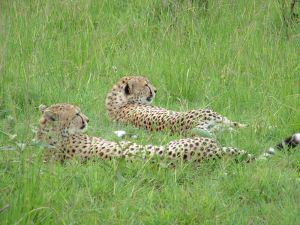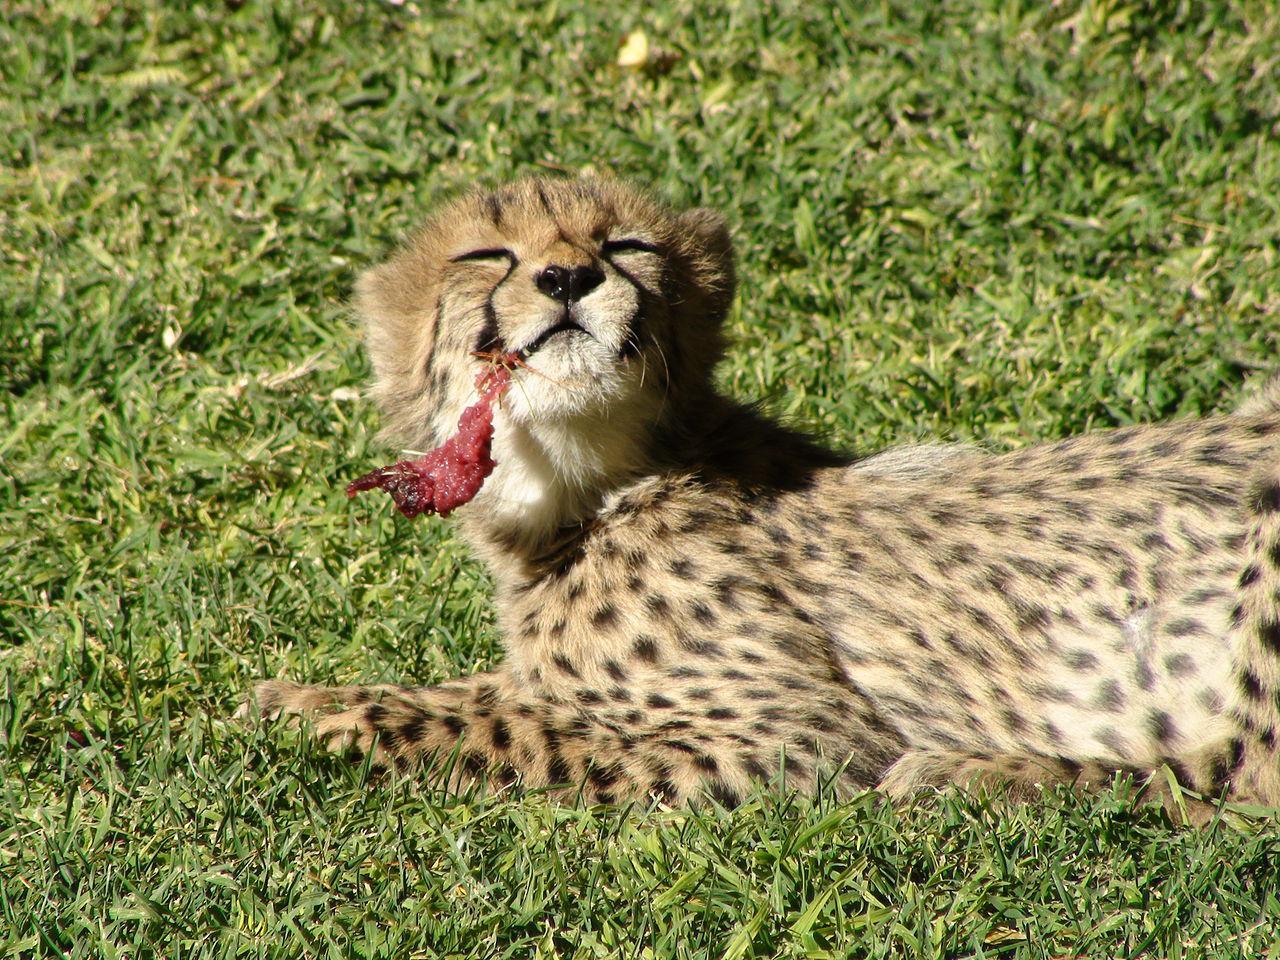The first image is the image on the left, the second image is the image on the right. Evaluate the accuracy of this statement regarding the images: "There are two cheetahs in the image pair". Is it true? Answer yes or no. No. The first image is the image on the left, the second image is the image on the right. Analyze the images presented: Is the assertion "There are three cheetahs." valid? Answer yes or no. Yes. 